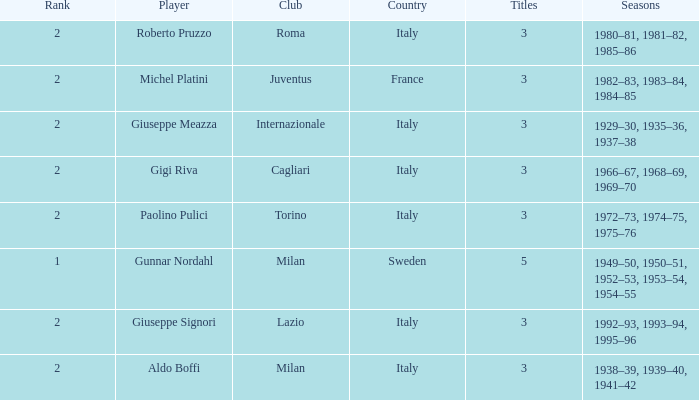How many rankings are associated with giuseppe meazza holding over 3 titles? 0.0. 